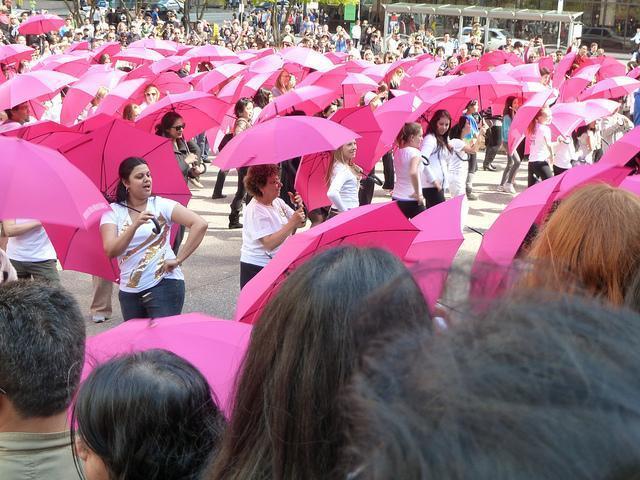How many people are in the picture?
Give a very brief answer. 8. How many umbrellas are there?
Give a very brief answer. 7. How many train cars are behind the locomotive?
Give a very brief answer. 0. 